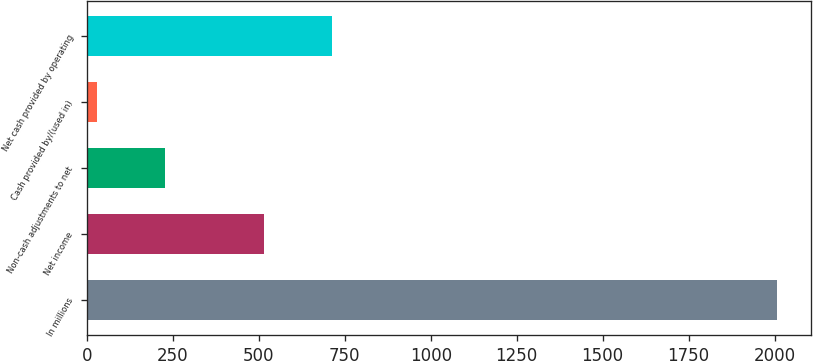<chart> <loc_0><loc_0><loc_500><loc_500><bar_chart><fcel>In millions<fcel>Net income<fcel>Non-cash adjustments to net<fcel>Cash provided by/(used in)<fcel>Net cash provided by operating<nl><fcel>2007<fcel>515.4<fcel>226.71<fcel>28.9<fcel>713.21<nl></chart> 